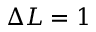Convert formula to latex. <formula><loc_0><loc_0><loc_500><loc_500>\Delta L = 1</formula> 